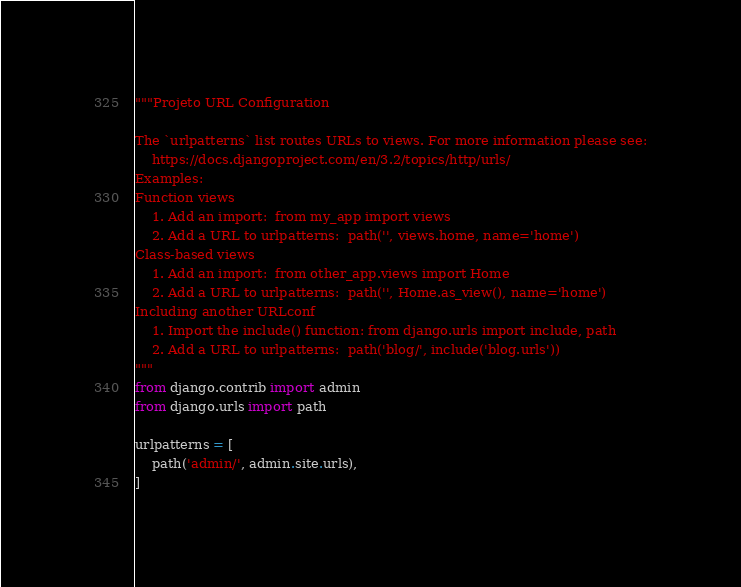<code> <loc_0><loc_0><loc_500><loc_500><_Python_>"""Projeto URL Configuration

The `urlpatterns` list routes URLs to views. For more information please see:
    https://docs.djangoproject.com/en/3.2/topics/http/urls/
Examples:
Function views
    1. Add an import:  from my_app import views
    2. Add a URL to urlpatterns:  path('', views.home, name='home')
Class-based views
    1. Add an import:  from other_app.views import Home
    2. Add a URL to urlpatterns:  path('', Home.as_view(), name='home')
Including another URLconf
    1. Import the include() function: from django.urls import include, path
    2. Add a URL to urlpatterns:  path('blog/', include('blog.urls'))
"""
from django.contrib import admin
from django.urls import path

urlpatterns = [
    path('admin/', admin.site.urls),
]
</code> 